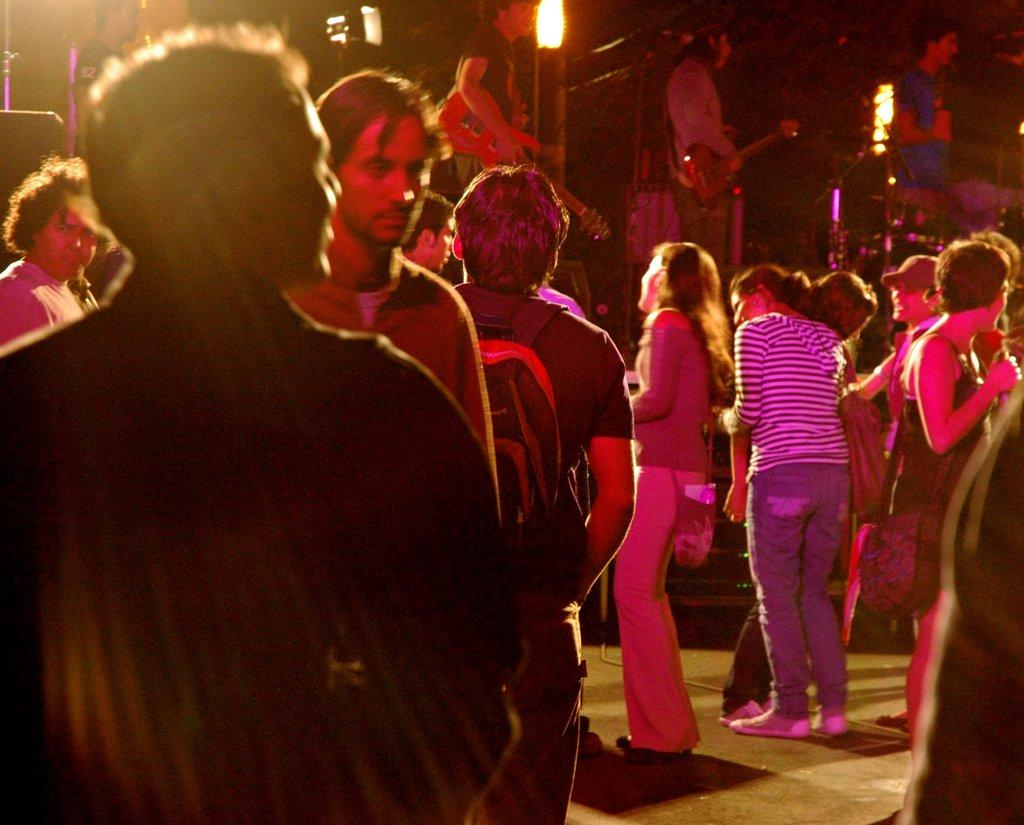What is the main subject of the image? There is a group of people in the image. Can you describe any specific activities or objects related to the group of people? In the background, there are two people holding guitars. What else can be seen in the image? There are lights visible in the image. What type of shoes is the kitty wearing while playing with the guitar strings in the image? There are no kitties or shoes present in the image. 